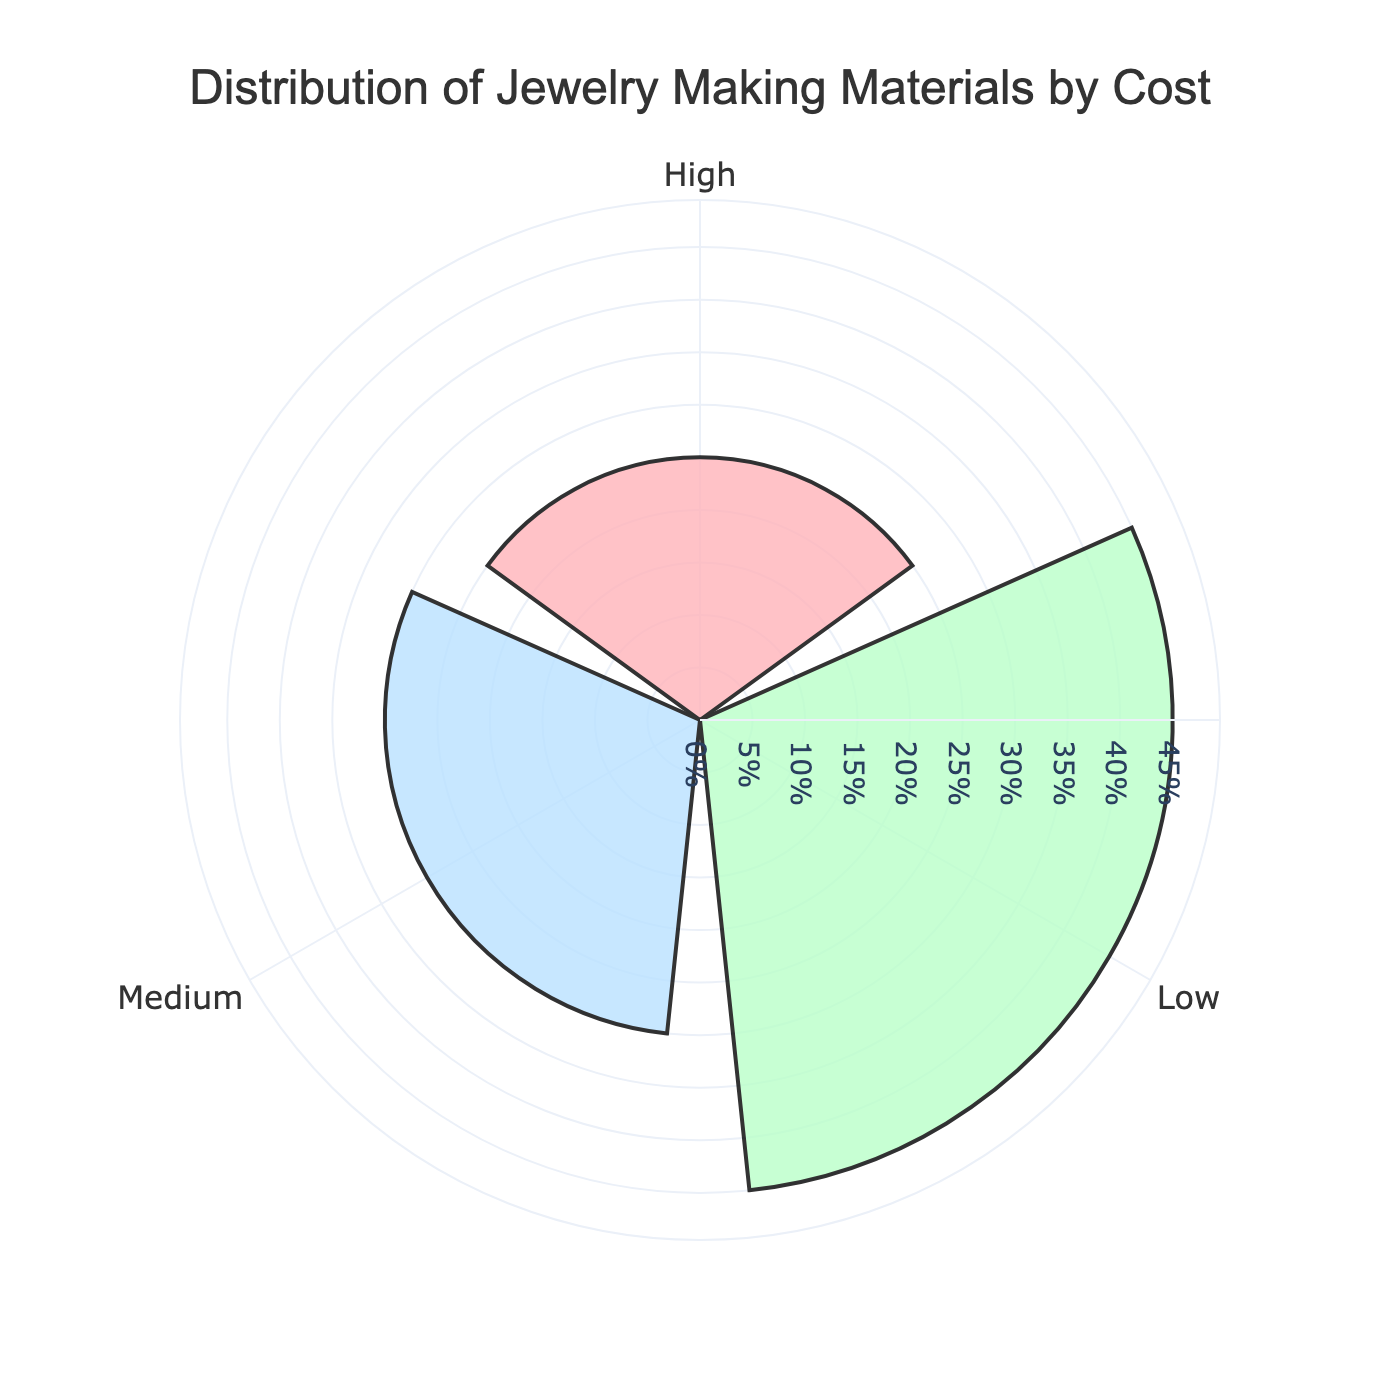What is the title of the chart? The title of the chart is shown at the top of the figure, and it reads "Distribution of Jewelry Making Materials by Cost."
Answer: Distribution of Jewelry Making Materials by Cost How many cost categories are there in the chart? The theta axis contains three distinct labels, indicating there are three cost categories: Low, Medium, and High.
Answer: Three Which cost category has the highest percentage? The radial axis (r) value is highest for the "Low" category, indicating it has the highest percentage.
Answer: Low What is the combined percentage of medium and high cost categories? From the chart, the "Medium" category has a 30% (15% + 15%) share, and the "High" category has a combined 25% (10% + 10% + 5%) share. Adding these together gives 55%.
Answer: 55% How do the percentages for the low and high cost categories compare? The low category has a percentage of 45%, while the high category has a percentage of 25%. Comparing these values, the low category has a higher percentage than the high category.
Answer: Low is greater What is the total percentage represented by the chart? Adding the individual percentages from all categories (25% + 20% + 15% + 15% + 10% + 10% + 5%) results in 100%.
Answer: 100% What is the difference between the percentages of low and medium cost categories? The low category sums up to 45% (25% + 20%), and the medium category sums up to 30% (15% + 15%). The difference is 45% - 30% = 15%.
Answer: 15% Which category among the bead materials is represented by the highest percentage, and what is that percentage? Among the bead materials, "Beads" have the highest percentage, represented within the "Low" cost category, with a percentage of 25%.
Answer: Beads with 25% How does the percentage represented by gold-filled findings compare to that of sterling silver? Both "Gold-filled Findings" and "Sterling Silver" fall in the "High" cost category, each contributing 10%. Hence, their percentages are equal.
Answer: Equal What percentage do elastic cords contribute to the total? Elastic cords are part of the "Low" cost category and contribute 20% to the total.
Answer: 20% 